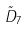Convert formula to latex. <formula><loc_0><loc_0><loc_500><loc_500>\tilde { D } _ { 7 }</formula> 